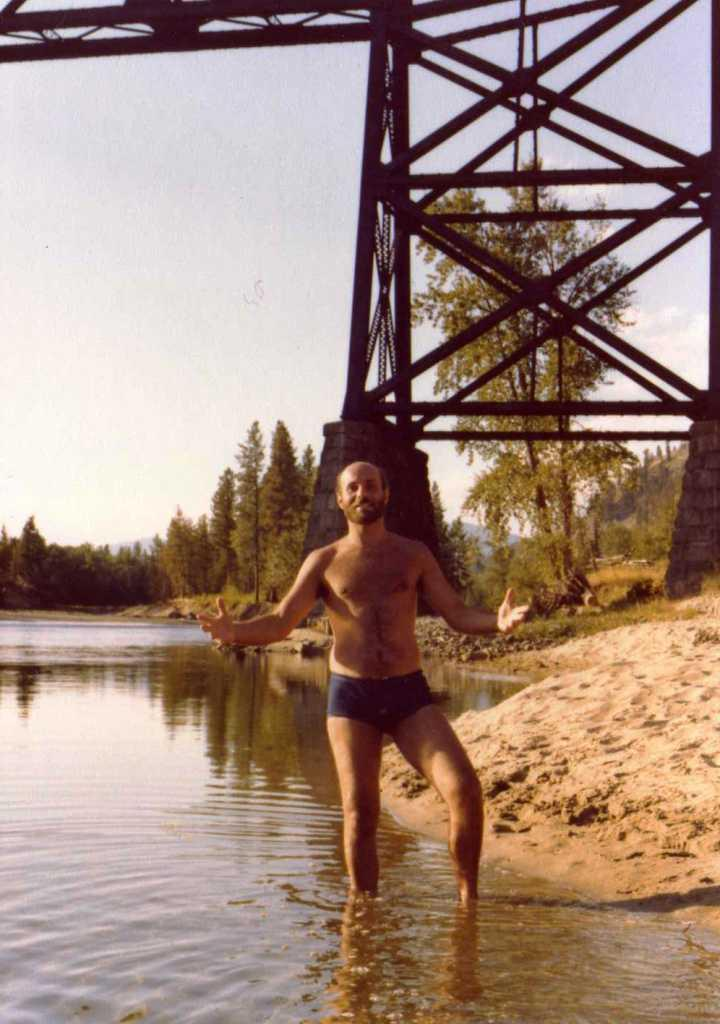What is the person in the image doing? The person is standing in the water. What type of vegetation can be seen in the image? There are trees and grass in the image. What objects are present in the water? There are rods in the water. What type of ground surface is visible in the image? There is sand in the image. What can be seen in the background of the image? The sky is visible in the background of the image. What type of eggs can be seen in the image? There are no eggs present in the image. What language is the person speaking in the image? The image does not provide any information about the person speaking or any language being spoken. 